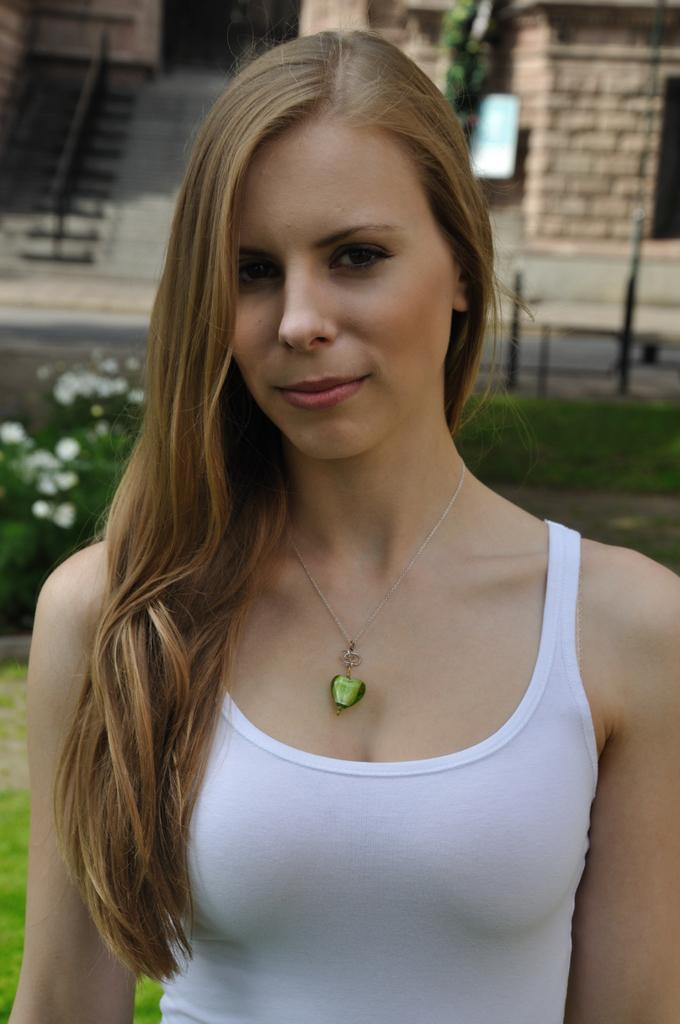Who is the main subject in the image? There is a woman standing in the middle of the image. What is the woman doing in the image? The woman is smiling in the image. What type of vegetation is visible behind the woman? There are plants and grass visible behind the woman. What type of structure can be seen at the top of the image? There is no seashore present in the image. What color is the orange bulb in the image? There is no orange bulb present in the image. Can you tell me how many seashores are visible in the image? There is no seashore present in the image. What type of fruit is the woman holding in the image? There is no fruit visible in the image. 